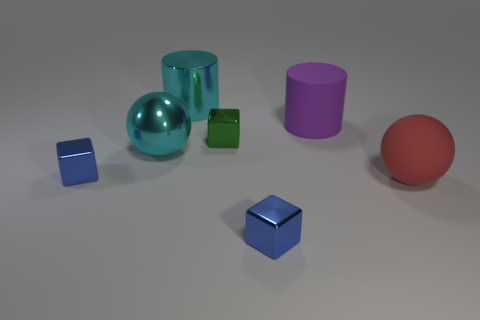Subtract all green blocks. How many blocks are left? 2 Add 2 green matte blocks. How many objects exist? 9 Subtract all green blocks. How many blocks are left? 2 Subtract 2 balls. How many balls are left? 0 Subtract all red cubes. Subtract all cyan cylinders. How many cubes are left? 3 Subtract all blue balls. How many cyan cylinders are left? 1 Subtract all big purple objects. Subtract all big red rubber spheres. How many objects are left? 5 Add 3 blue cubes. How many blue cubes are left? 5 Add 5 big metal spheres. How many big metal spheres exist? 6 Subtract 0 green balls. How many objects are left? 7 